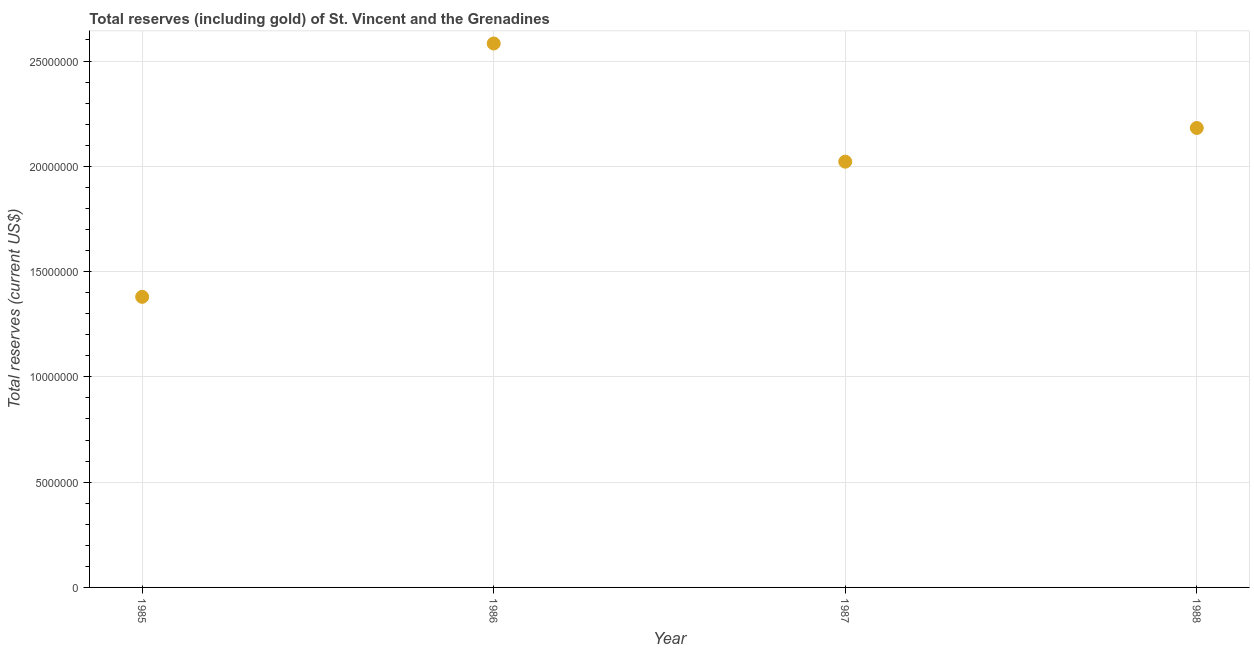What is the total reserves (including gold) in 1986?
Provide a short and direct response. 2.58e+07. Across all years, what is the maximum total reserves (including gold)?
Your response must be concise. 2.58e+07. Across all years, what is the minimum total reserves (including gold)?
Keep it short and to the point. 1.38e+07. In which year was the total reserves (including gold) maximum?
Make the answer very short. 1986. What is the sum of the total reserves (including gold)?
Your answer should be very brief. 8.17e+07. What is the difference between the total reserves (including gold) in 1985 and 1986?
Offer a very short reply. -1.20e+07. What is the average total reserves (including gold) per year?
Your answer should be compact. 2.04e+07. What is the median total reserves (including gold)?
Provide a short and direct response. 2.10e+07. What is the ratio of the total reserves (including gold) in 1985 to that in 1987?
Ensure brevity in your answer.  0.68. Is the total reserves (including gold) in 1986 less than that in 1987?
Make the answer very short. No. Is the difference between the total reserves (including gold) in 1985 and 1987 greater than the difference between any two years?
Offer a very short reply. No. What is the difference between the highest and the second highest total reserves (including gold)?
Your response must be concise. 4.01e+06. Is the sum of the total reserves (including gold) in 1987 and 1988 greater than the maximum total reserves (including gold) across all years?
Your answer should be compact. Yes. What is the difference between the highest and the lowest total reserves (including gold)?
Your answer should be compact. 1.20e+07. In how many years, is the total reserves (including gold) greater than the average total reserves (including gold) taken over all years?
Provide a succinct answer. 2. How many dotlines are there?
Offer a terse response. 1. Are the values on the major ticks of Y-axis written in scientific E-notation?
Provide a short and direct response. No. Does the graph contain any zero values?
Ensure brevity in your answer.  No. What is the title of the graph?
Your response must be concise. Total reserves (including gold) of St. Vincent and the Grenadines. What is the label or title of the X-axis?
Provide a short and direct response. Year. What is the label or title of the Y-axis?
Offer a very short reply. Total reserves (current US$). What is the Total reserves (current US$) in 1985?
Offer a very short reply. 1.38e+07. What is the Total reserves (current US$) in 1986?
Your answer should be very brief. 2.58e+07. What is the Total reserves (current US$) in 1987?
Offer a terse response. 2.02e+07. What is the Total reserves (current US$) in 1988?
Offer a very short reply. 2.18e+07. What is the difference between the Total reserves (current US$) in 1985 and 1986?
Keep it short and to the point. -1.20e+07. What is the difference between the Total reserves (current US$) in 1985 and 1987?
Keep it short and to the point. -6.42e+06. What is the difference between the Total reserves (current US$) in 1985 and 1988?
Make the answer very short. -8.02e+06. What is the difference between the Total reserves (current US$) in 1986 and 1987?
Your answer should be very brief. 5.61e+06. What is the difference between the Total reserves (current US$) in 1986 and 1988?
Ensure brevity in your answer.  4.01e+06. What is the difference between the Total reserves (current US$) in 1987 and 1988?
Provide a short and direct response. -1.60e+06. What is the ratio of the Total reserves (current US$) in 1985 to that in 1986?
Your answer should be very brief. 0.53. What is the ratio of the Total reserves (current US$) in 1985 to that in 1987?
Your response must be concise. 0.68. What is the ratio of the Total reserves (current US$) in 1985 to that in 1988?
Make the answer very short. 0.63. What is the ratio of the Total reserves (current US$) in 1986 to that in 1987?
Give a very brief answer. 1.28. What is the ratio of the Total reserves (current US$) in 1986 to that in 1988?
Your response must be concise. 1.18. What is the ratio of the Total reserves (current US$) in 1987 to that in 1988?
Make the answer very short. 0.93. 